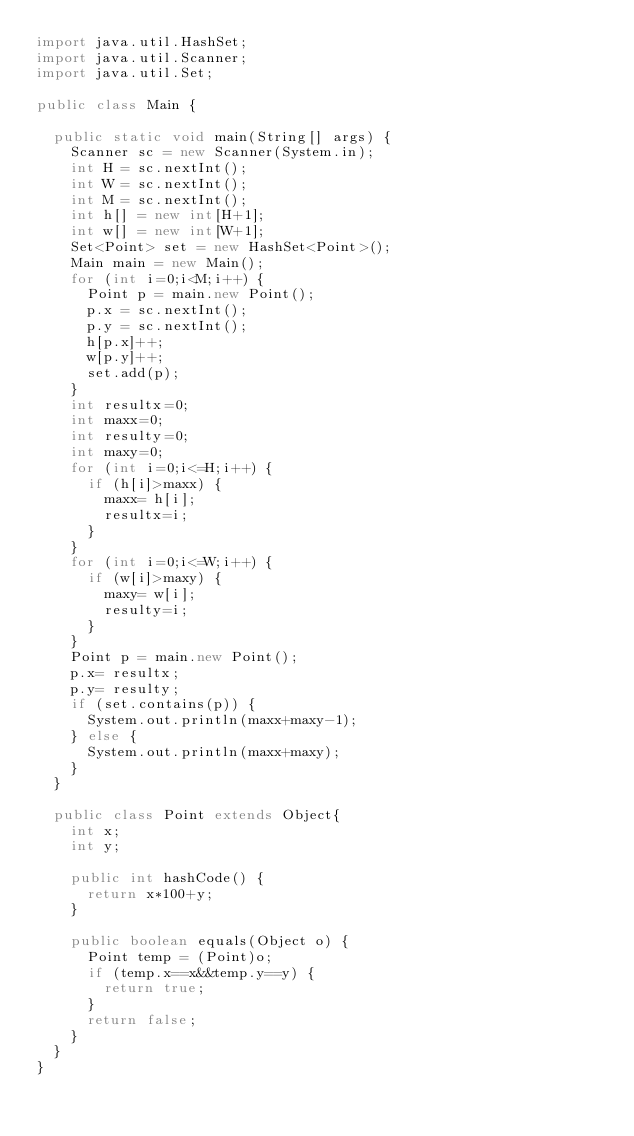Convert code to text. <code><loc_0><loc_0><loc_500><loc_500><_Java_>import java.util.HashSet;
import java.util.Scanner;
import java.util.Set;

public class Main {

	public static void main(String[] args) {
		Scanner sc = new Scanner(System.in);
		int H = sc.nextInt();
		int W = sc.nextInt();
		int M = sc.nextInt();
		int h[] = new int[H+1];
		int w[] = new int[W+1];
		Set<Point> set = new HashSet<Point>();
		Main main = new Main();
		for (int i=0;i<M;i++) {
			Point p = main.new Point();
			p.x = sc.nextInt();
			p.y = sc.nextInt();
			h[p.x]++;
			w[p.y]++;
			set.add(p);
		}
		int resultx=0;
		int maxx=0;
		int resulty=0;
		int maxy=0;
		for (int i=0;i<=H;i++) {
			if (h[i]>maxx) {
				maxx= h[i];
				resultx=i;
			}
		}
		for (int i=0;i<=W;i++) {
			if (w[i]>maxy) {
				maxy= w[i];
				resulty=i;
			}
		}
		Point p = main.new Point();
		p.x= resultx;
		p.y= resulty;
		if (set.contains(p)) {
			System.out.println(maxx+maxy-1);
		} else {
			System.out.println(maxx+maxy);
		}
	}

	public class Point extends Object{
		int x;
		int y;

		public int hashCode() {
			return x*100+y;
		}

		public boolean equals(Object o) {
			Point temp = (Point)o;
			if (temp.x==x&&temp.y==y) {
				return true;
			}
			return false;
		}
	}
}</code> 